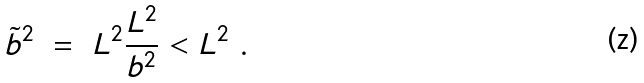Convert formula to latex. <formula><loc_0><loc_0><loc_500><loc_500>\tilde { b } ^ { 2 } \ = \ L ^ { 2 } \frac { L ^ { 2 } } { b ^ { 2 } } < L ^ { 2 } \ .</formula> 